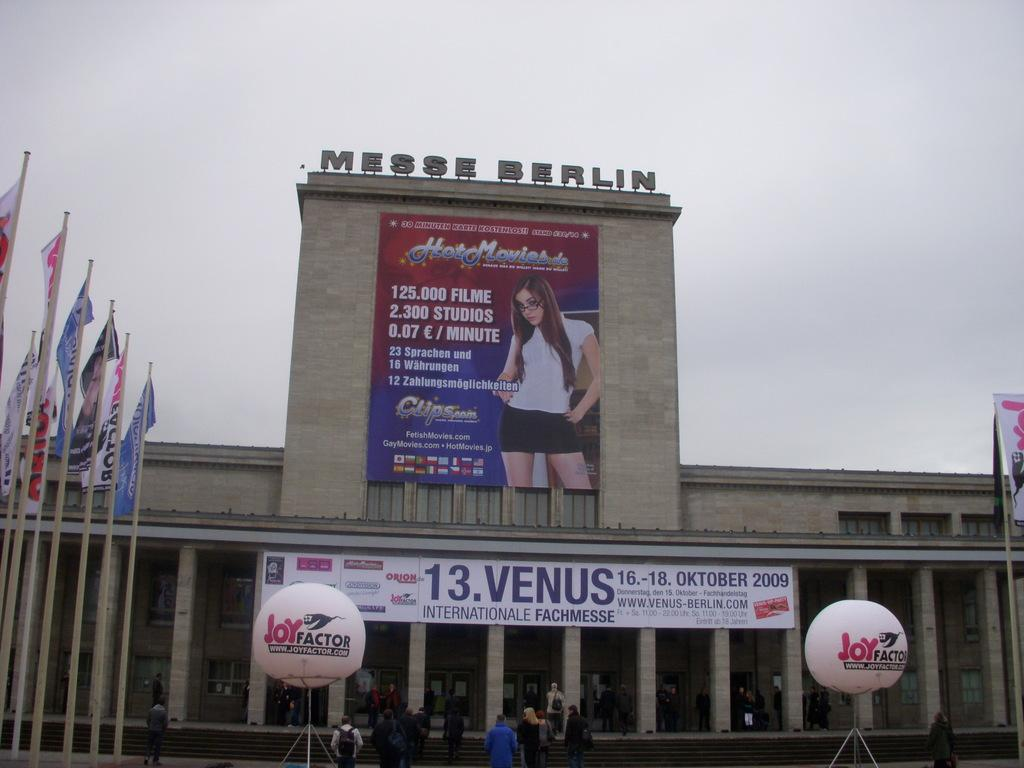<image>
Create a compact narrative representing the image presented. the Messe Berlin building with posters and balloons in front 